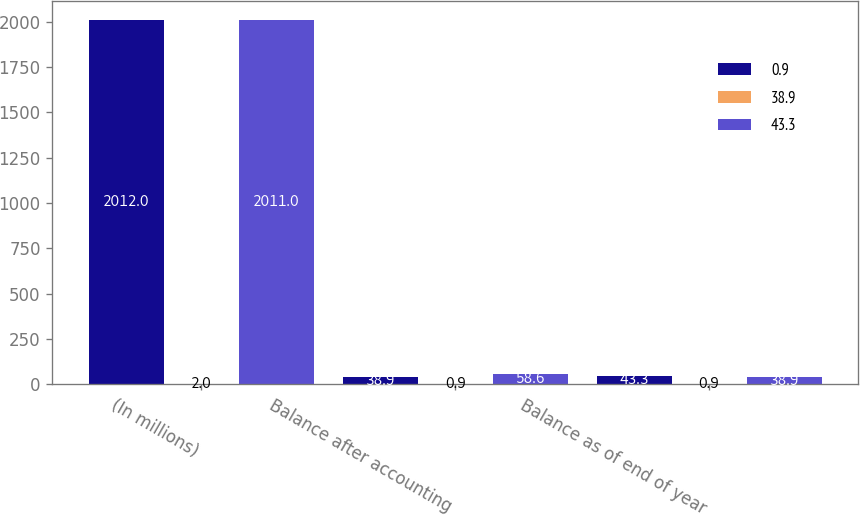<chart> <loc_0><loc_0><loc_500><loc_500><stacked_bar_chart><ecel><fcel>(In millions)<fcel>Balance after accounting<fcel>Balance as of end of year<nl><fcel>0.9<fcel>2012<fcel>38.9<fcel>43.3<nl><fcel>38.9<fcel>2<fcel>0.9<fcel>0.9<nl><fcel>43.3<fcel>2011<fcel>58.6<fcel>38.9<nl></chart> 